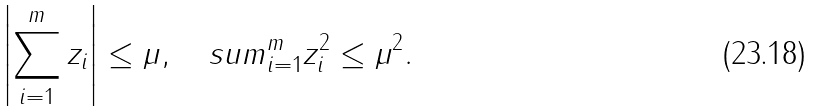<formula> <loc_0><loc_0><loc_500><loc_500>\left | \sum _ { i = 1 } ^ { m } z _ { i } \right | \leq \mu , \quad s u m _ { i = 1 } ^ { m } z _ { i } ^ { 2 } \leq \mu ^ { 2 } .</formula> 